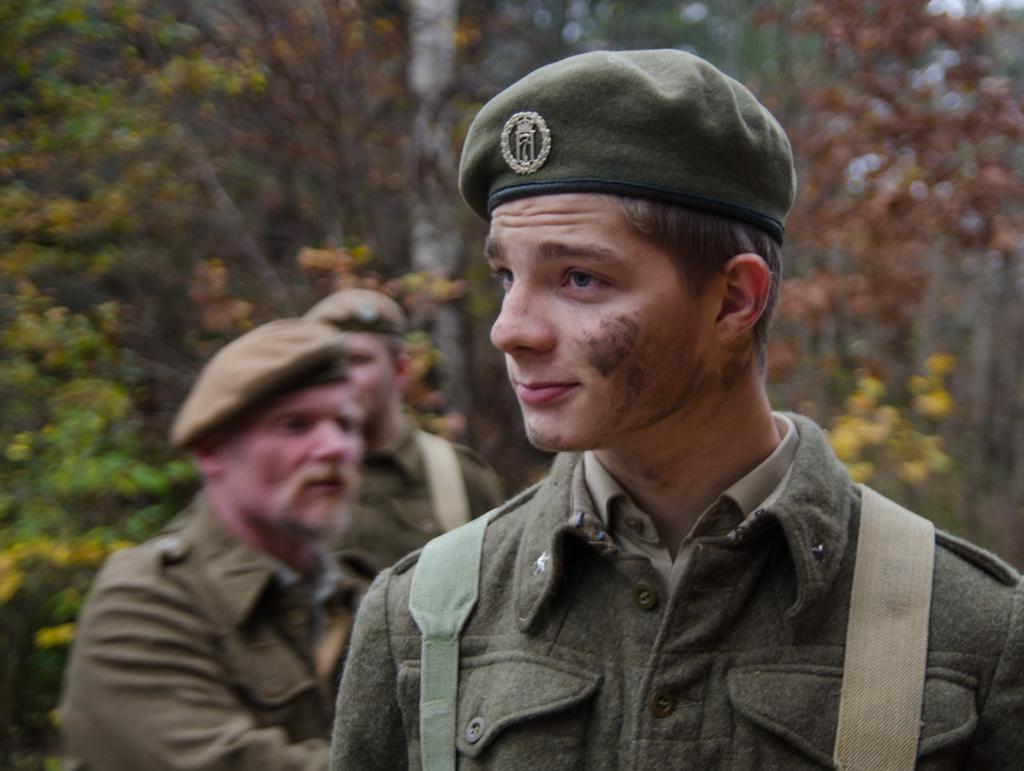Can you describe this image briefly? In this image we can see man standing. In the background we can see trees. 